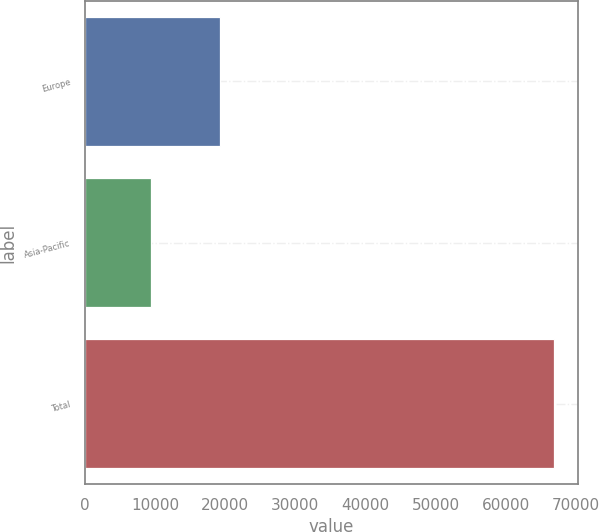<chart> <loc_0><loc_0><loc_500><loc_500><bar_chart><fcel>Europe<fcel>Asia-Pacific<fcel>Total<nl><fcel>19331<fcel>9363<fcel>66913<nl></chart> 